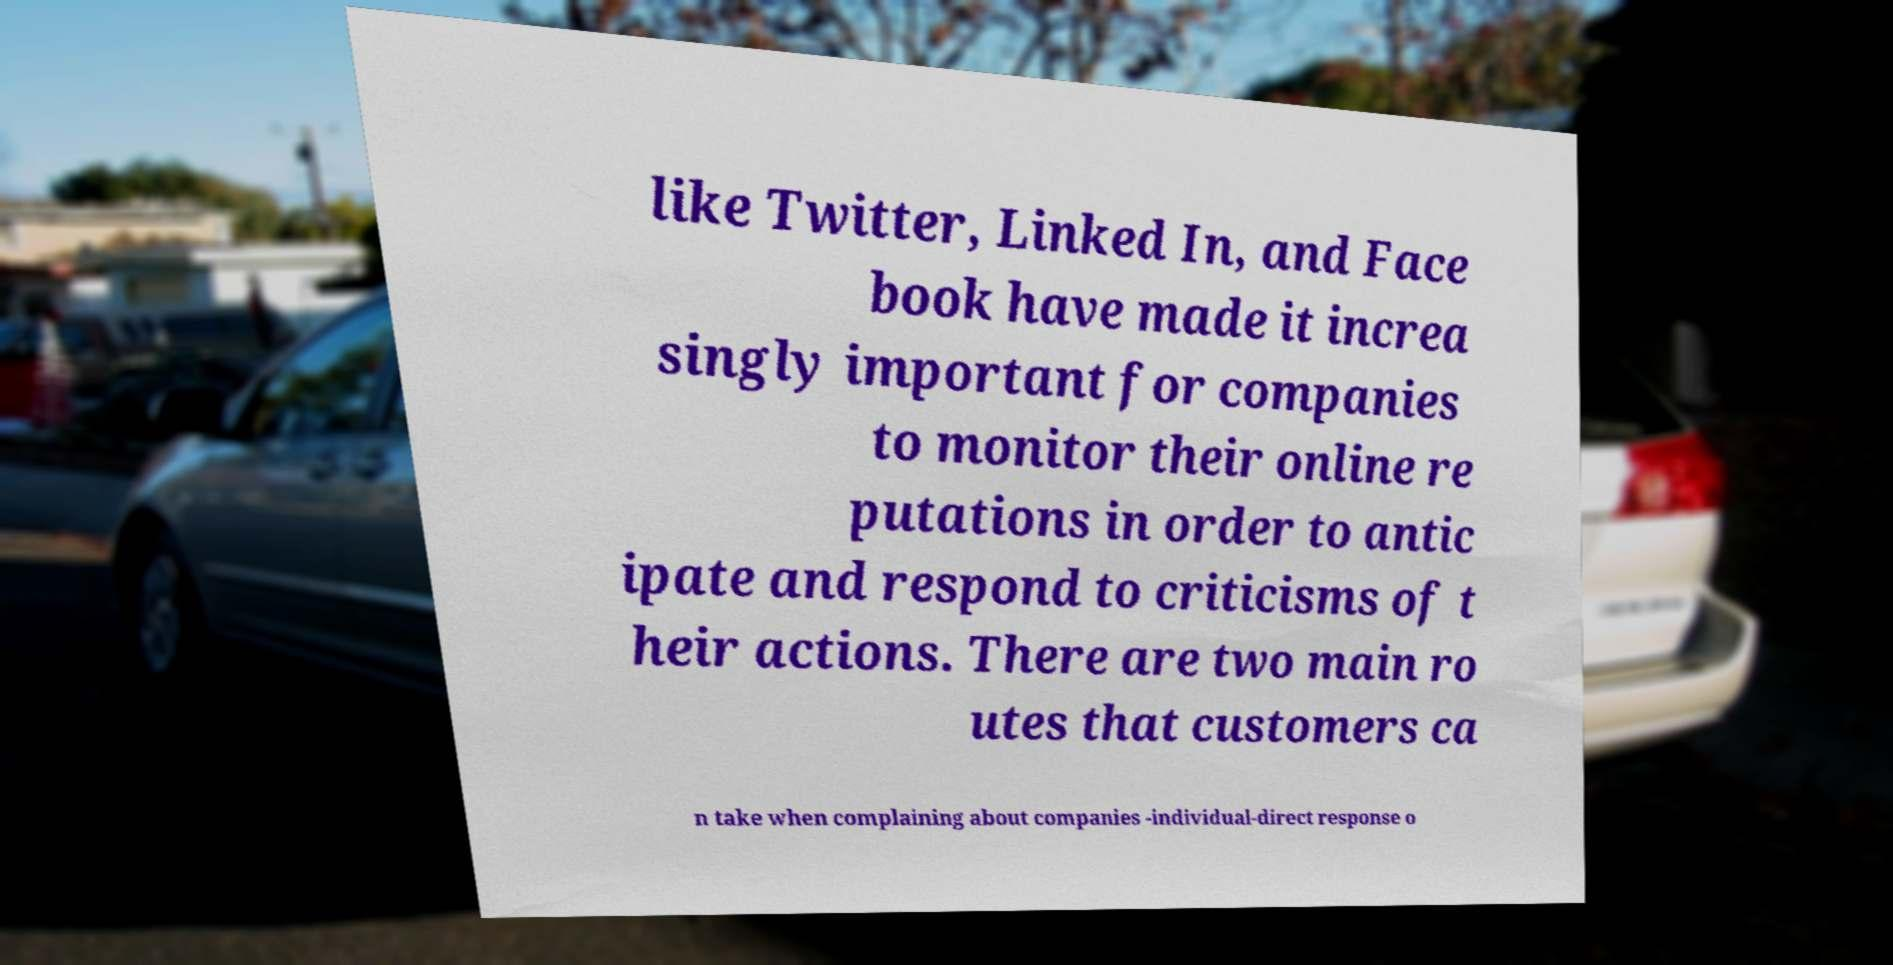Can you read and provide the text displayed in the image?This photo seems to have some interesting text. Can you extract and type it out for me? like Twitter, Linked In, and Face book have made it increa singly important for companies to monitor their online re putations in order to antic ipate and respond to criticisms of t heir actions. There are two main ro utes that customers ca n take when complaining about companies -individual-direct response o 